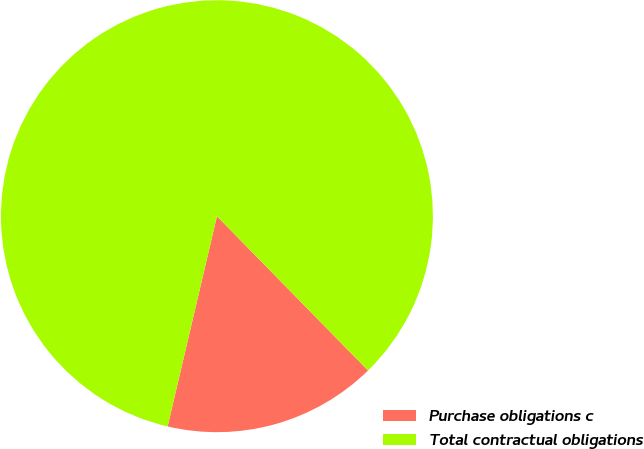<chart> <loc_0><loc_0><loc_500><loc_500><pie_chart><fcel>Purchase obligations c<fcel>Total contractual obligations<nl><fcel>16.0%<fcel>84.0%<nl></chart> 